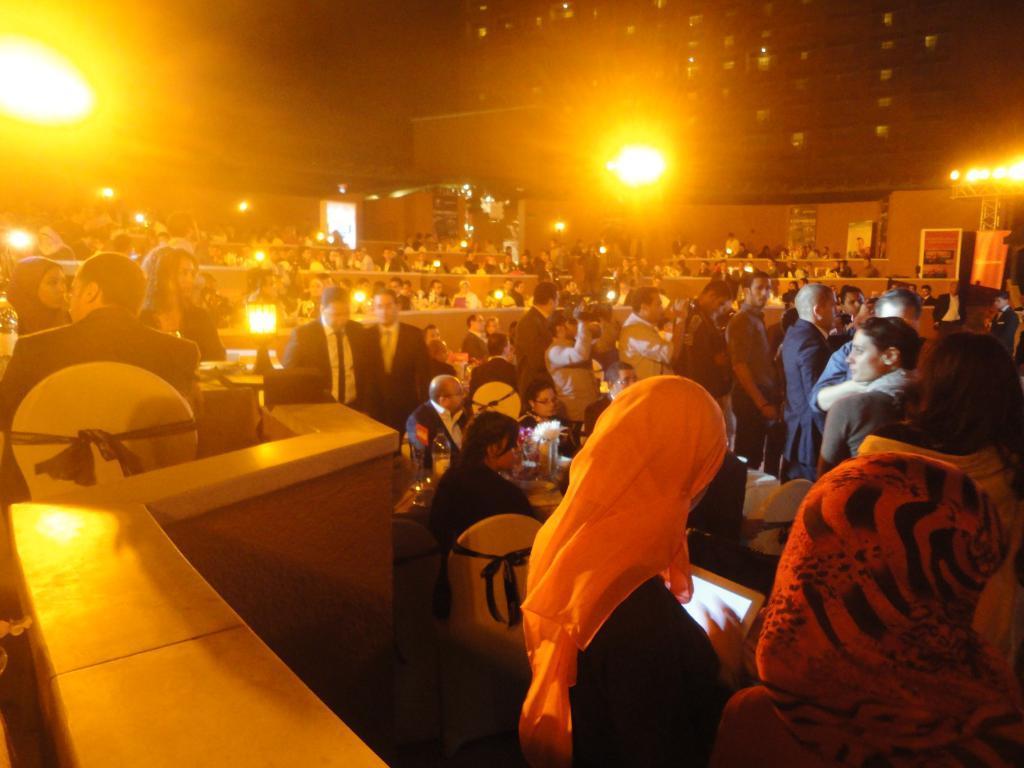Can you describe this image briefly? There are group of people sitting in the right corner and the remaining people are sitting and there is a yellow light on the either side of them. 